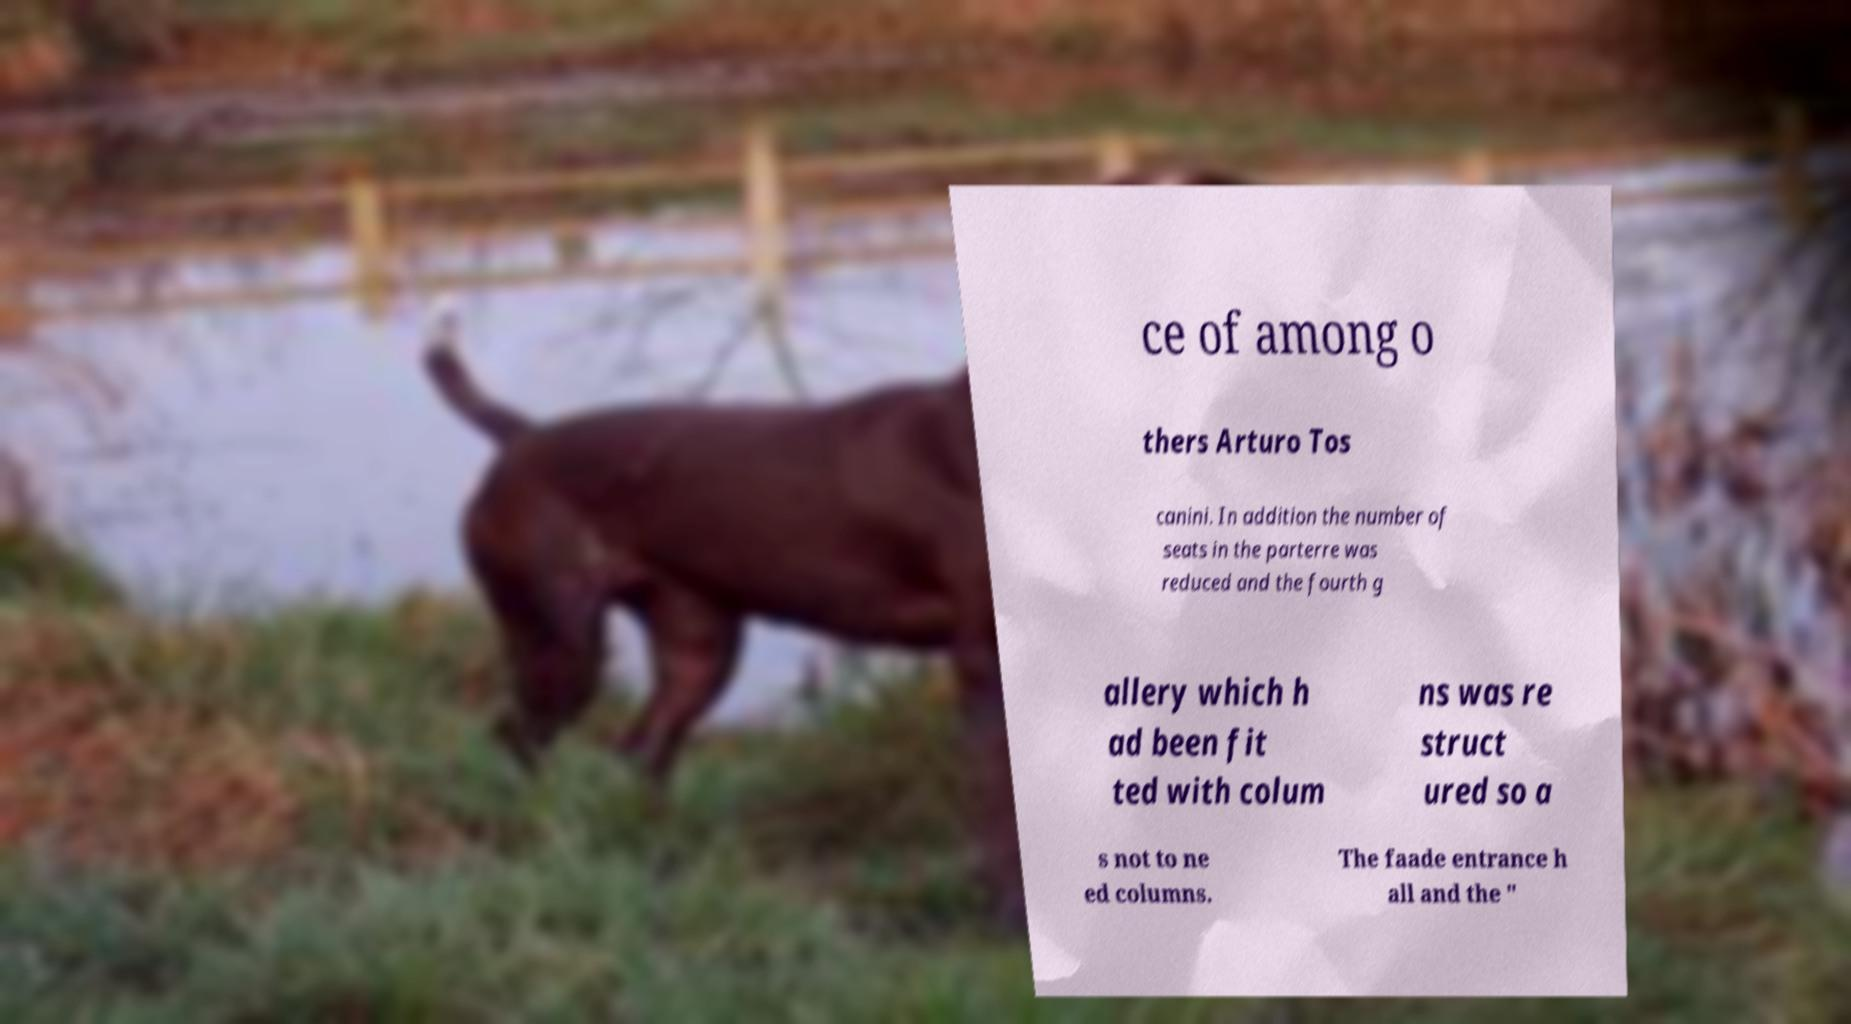Can you read and provide the text displayed in the image?This photo seems to have some interesting text. Can you extract and type it out for me? ce of among o thers Arturo Tos canini. In addition the number of seats in the parterre was reduced and the fourth g allery which h ad been fit ted with colum ns was re struct ured so a s not to ne ed columns. The faade entrance h all and the " 